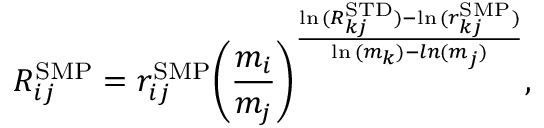Convert formula to latex. <formula><loc_0><loc_0><loc_500><loc_500>R _ { i j } ^ { S M P } = r _ { i j } ^ { S M P } { \left ( \frac { m _ { i } } { m _ { j } } \right ) } ^ { \frac { \ln { ( R _ { k j } ^ { S T D } ) } - \ln { ( r _ { k j } ^ { S M P } ) } } { \ln { ( m _ { k } ) } - \ln { ( m _ { j } ) } } } ,</formula> 